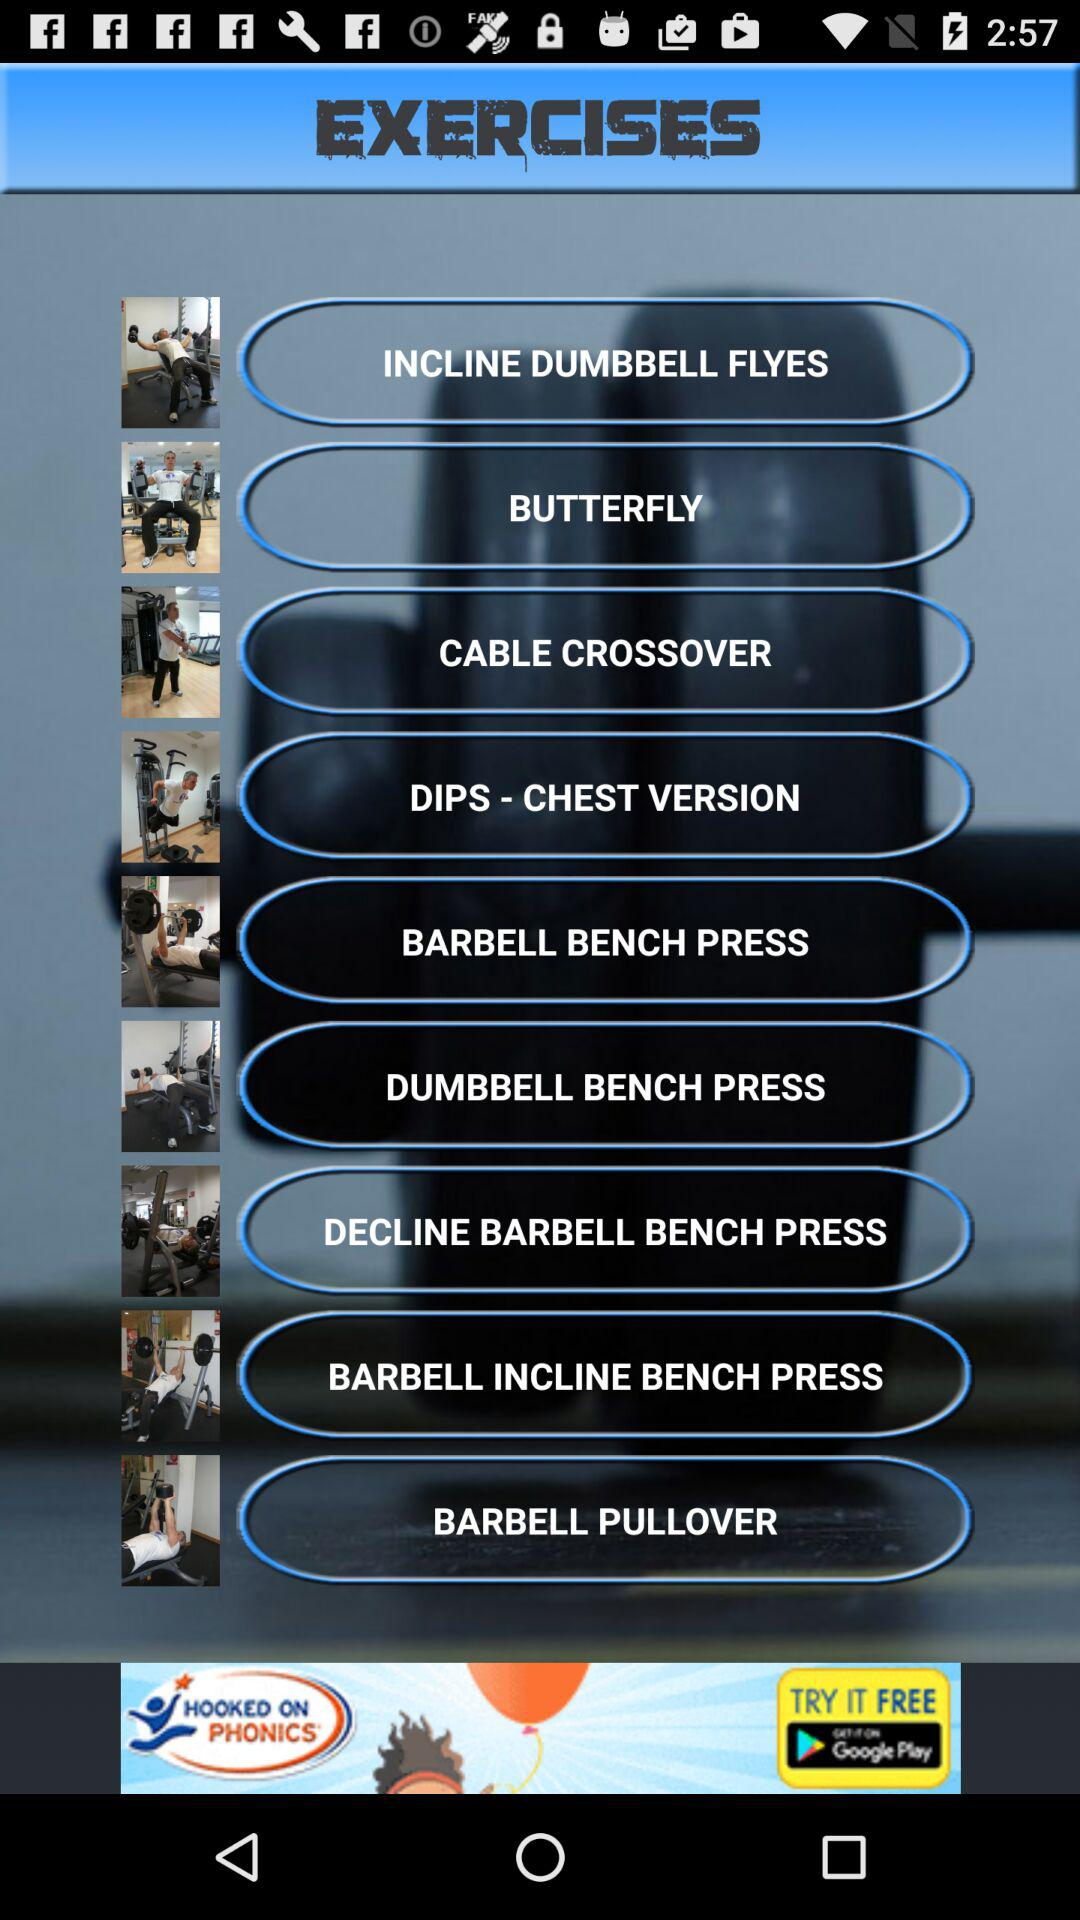What are the different types of exercises? The different types of exercises are incline dumbbell flyes, butterfly, cable crossover, dips-chest version, barbell bench press, dumbbell bench press, decline barbell bench press, barbell incline bench press and barbell pullover. 